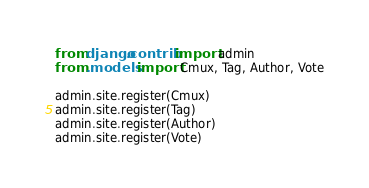<code> <loc_0><loc_0><loc_500><loc_500><_Python_>from django.contrib import admin
from .models import Cmux, Tag, Author, Vote

admin.site.register(Cmux)
admin.site.register(Tag)
admin.site.register(Author)
admin.site.register(Vote)
</code> 